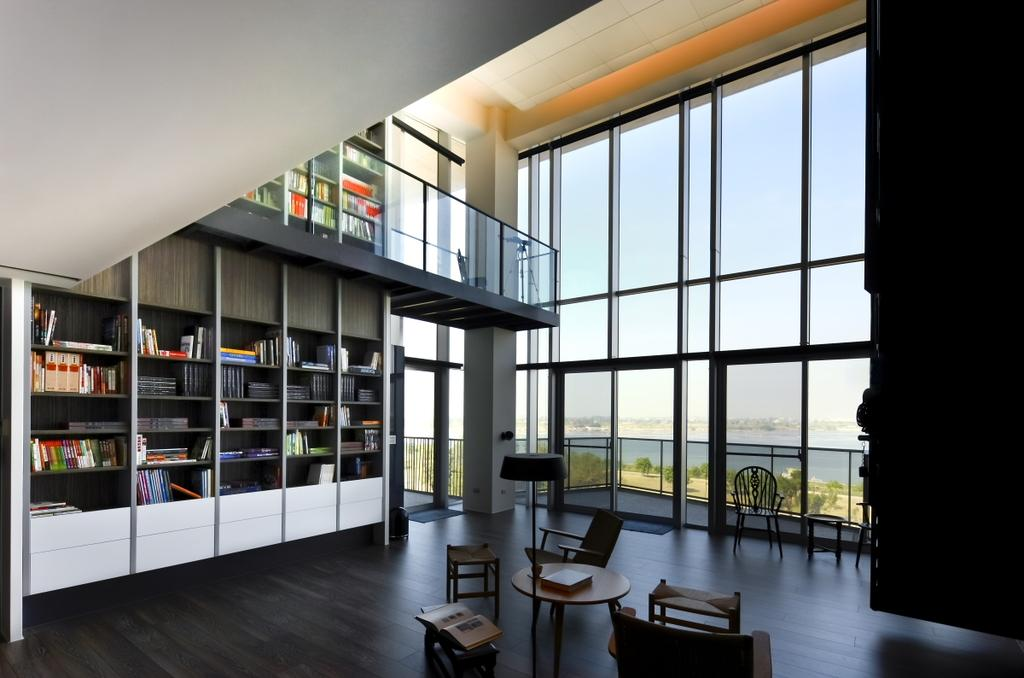What can be seen on the shelves in the image? There are books arranged in shelves in the image. What furniture is present in the room? There is a table and chairs in the image. What architectural features can be seen in the room? There is a door in the image. What is visible through the windows in the image? There are windows in the image, and water, trees, and the sky are visible in the background. How many sheep are grazing on the range in the image? There are no sheep or range present in the image. What type of fork is used to eat the food on the table in the image? There is no fork visible in the image, and no food is being eaten. 